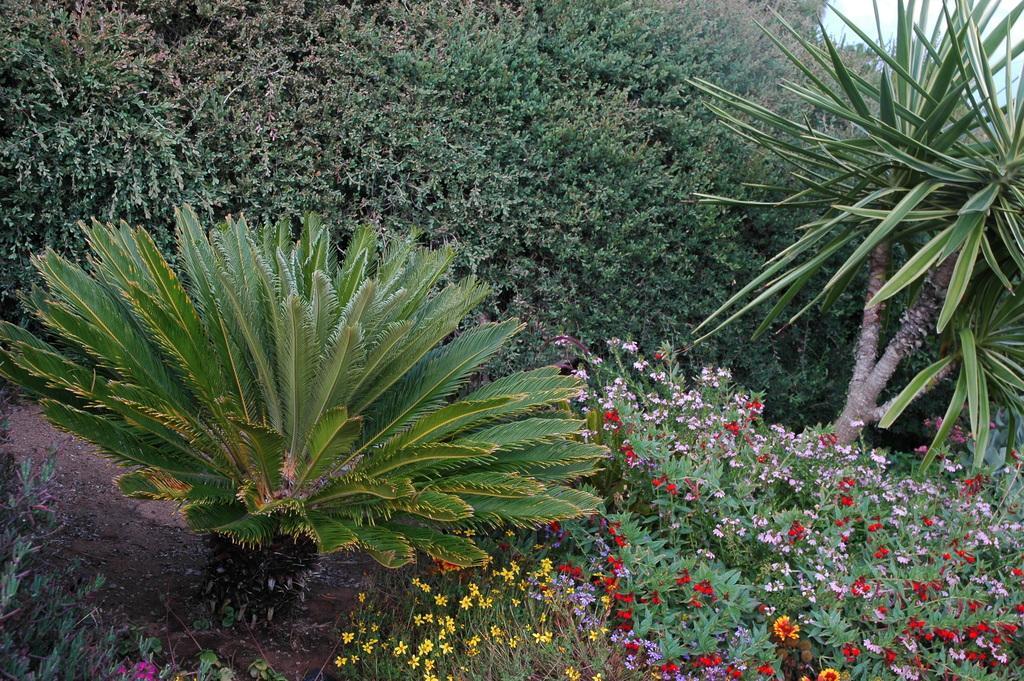Could you give a brief overview of what you see in this image? In this picture there are flower plants at the bottom side of the image and there is greenery around the area of the image. 